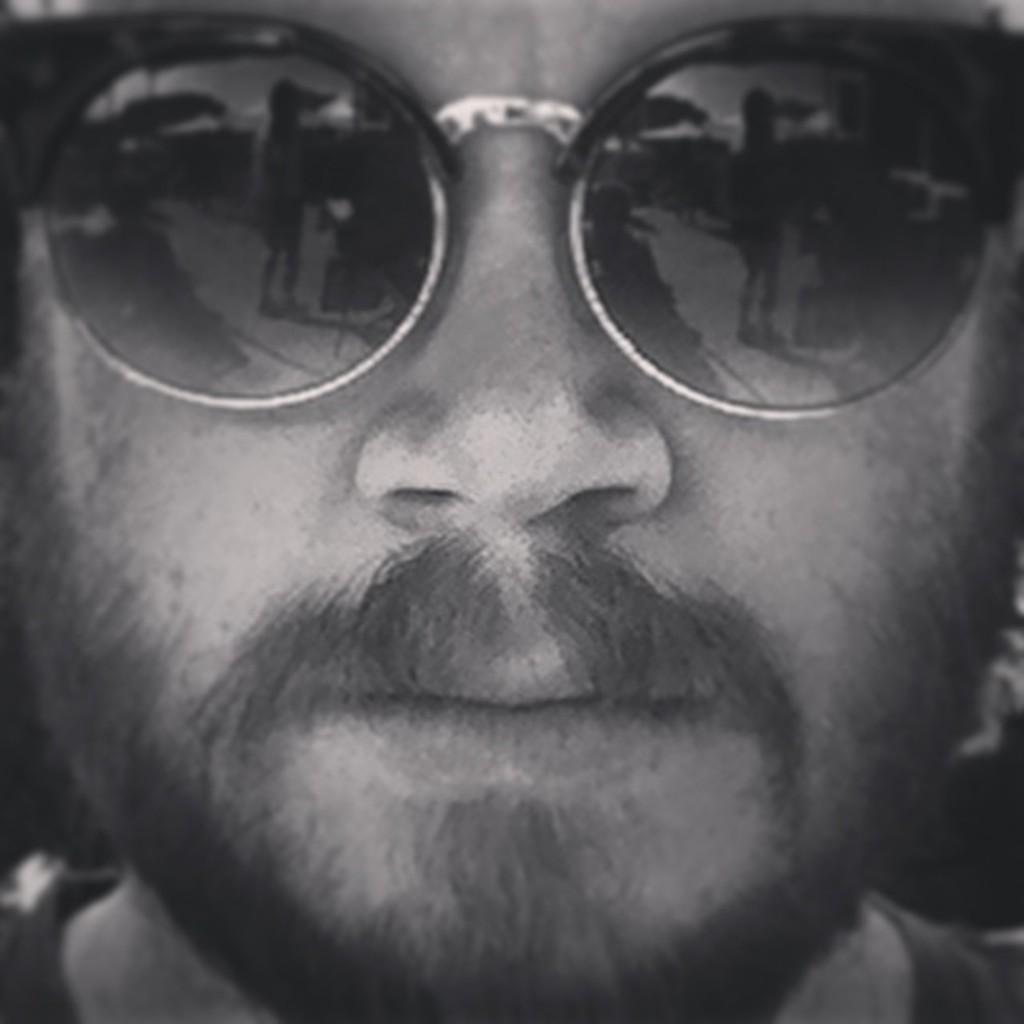What is the main subject of the image? The main subject of the image is a man's face. What facial feature can be observed on the man? The man has a beard. What accessory is the man wearing in the image? The man is wearing black sunglasses. What type of wine is the man holding in the image? There is no wine present in the image; it only shows a close view of the man's face. Can you describe the toad that is sitting on the man's shoulder in the image? There is no toad present in the image; the man's face is the only subject visible. 